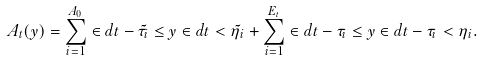Convert formula to latex. <formula><loc_0><loc_0><loc_500><loc_500>A _ { t } ( y ) = \sum _ { i = 1 } ^ { A _ { 0 } } \in d { t - \tilde { \tau _ { i } } \leq y } \in d { t < \tilde { \eta } _ { i } } + \sum _ { i = 1 } ^ { E _ { t } } \in d { t - \tau _ { i } \leq y } \in d { t - \tau _ { i } < \eta _ { i } } .</formula> 